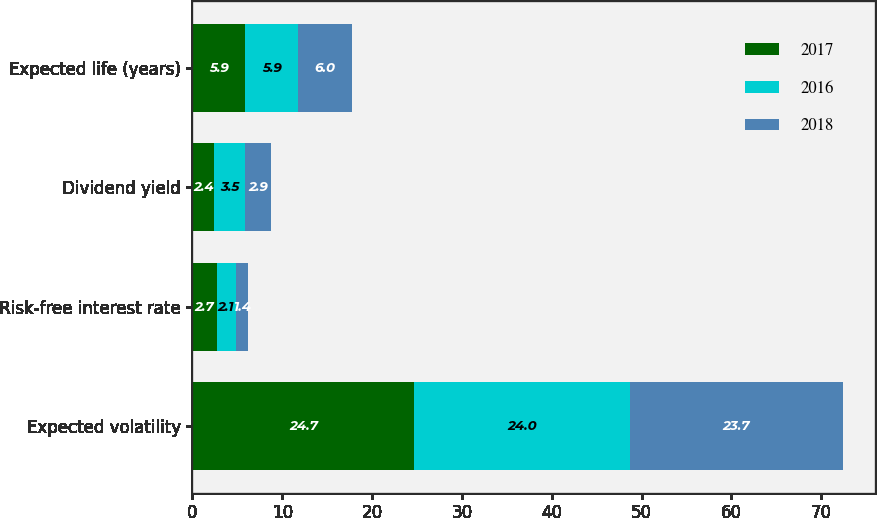<chart> <loc_0><loc_0><loc_500><loc_500><stacked_bar_chart><ecel><fcel>Expected volatility<fcel>Risk-free interest rate<fcel>Dividend yield<fcel>Expected life (years)<nl><fcel>2017<fcel>24.7<fcel>2.7<fcel>2.4<fcel>5.9<nl><fcel>2016<fcel>24<fcel>2.1<fcel>3.5<fcel>5.9<nl><fcel>2018<fcel>23.7<fcel>1.4<fcel>2.9<fcel>6<nl></chart> 